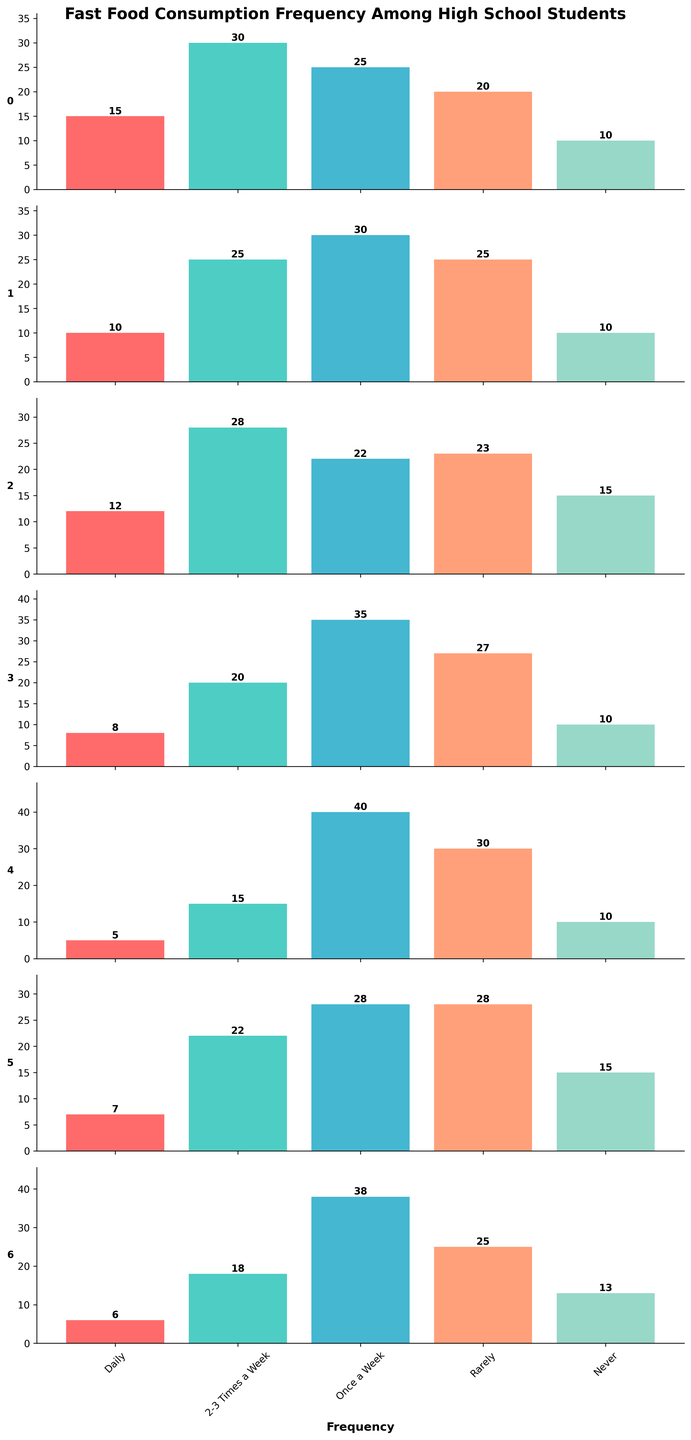Which restaurant has the highest number of students who eat there daily? Look at the values for the "Daily" column across all restaurants and find the maximum value. McDonald's has 15, which is the highest.
Answer: McDonald's How many students eat at Subway either daily or 2-3 times a week? Add the values for "Daily" and "2-3 Times a Week" columns for Subway: 5 (Daily) + 15 (2-3 Times a Week) = 20.
Answer: 20 Which restaurant has the least number of students who never eat there? Look at the "Never" column across all restaurants. Subway and McDonald's both have the lowest value of 10.
Answer: Subway and McDonald's What's the total number of students who eat at KFC at least once a week? Add the values for "Daily", "2-3 Times a Week", and "Once a Week" columns for KFC: 8 (Daily) + 20 (2-3 Times a Week) + 35 (Once a Week) = 63.
Answer: 63 How does the number of students who eat at Burger King rarely compare to those who eat at Wendy's rarely? Compare the values under the "Rarely" column for Burger King and Wendy's. Burger King has 25, and Wendy's has 28. So, Wendy's has 3 more students.
Answer: Wendy's has 3 more Which restaurant has the highest overall variability in consumption frequency? Look at the range (difference between max and min values) for each restaurant. Subway has the highest range with values between 5 and 40.
Answer: Subway If you combine the number of students who eat at McDonald's and Taco Bell daily, what do you get? Add the values for "Daily" from McDonald's and Taco Bell: 15 (McDonald's) + 12 (Taco Bell) = 27.
Answer: 27 Which two restaurants have the same number of students who never eat there? Find the restaurants with equal values in the "Never" column. McDonald's and KFC both have 10 students.
Answer: McDonald's and KFC How often do most students eat at Pizza Hut? Look for the highest value in Pizza Hut's row. For Pizza Hut, the highest value is 38 in the "Once a Week" column.
Answer: Once a Week What's the difference in the number of students who eat at Subway 2-3 times a week compared to those who eat at KFC 2-3 times a week? Subtract the "2-3 Times a Week" values of Subway and KFC. 20 (KFC) - 15 (Subway) = 5.
Answer: 5 